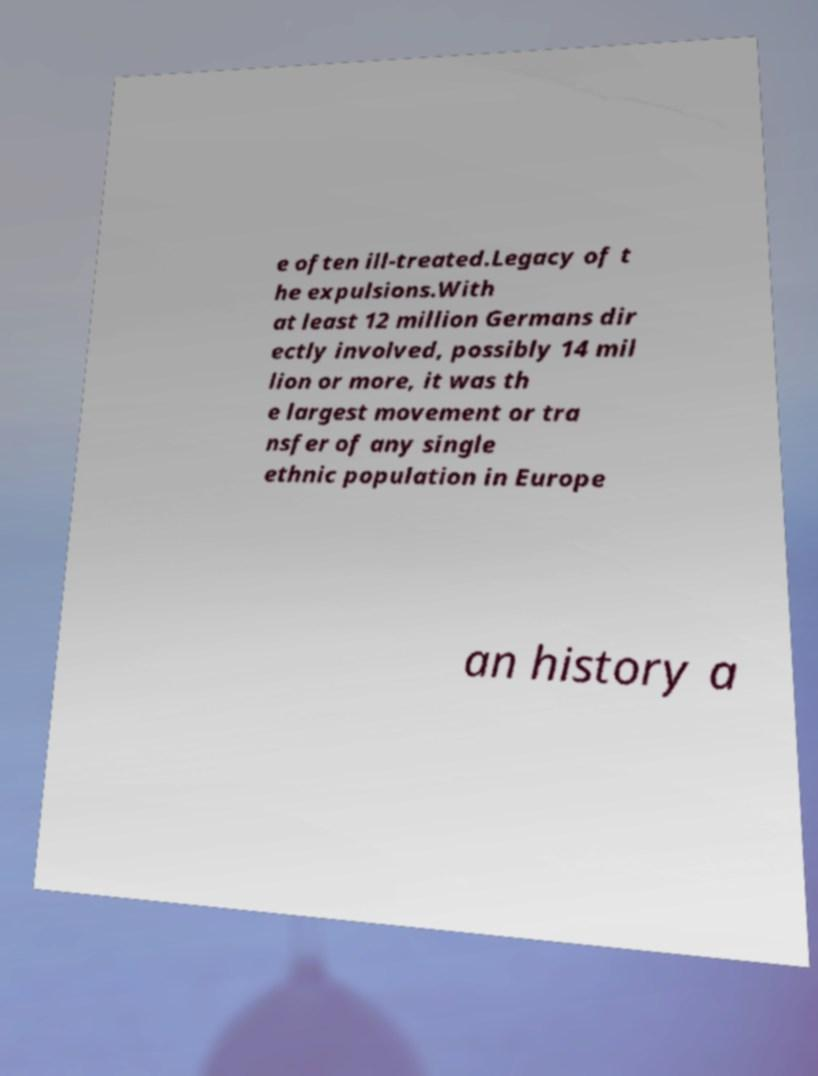For documentation purposes, I need the text within this image transcribed. Could you provide that? e often ill-treated.Legacy of t he expulsions.With at least 12 million Germans dir ectly involved, possibly 14 mil lion or more, it was th e largest movement or tra nsfer of any single ethnic population in Europe an history a 